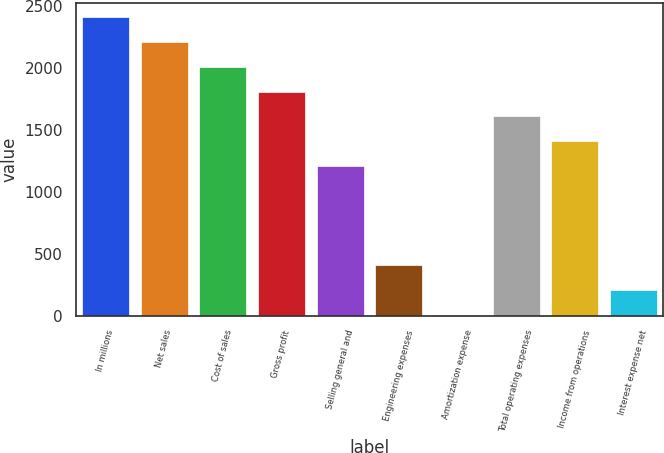Convert chart. <chart><loc_0><loc_0><loc_500><loc_500><bar_chart><fcel>In millions<fcel>Net sales<fcel>Cost of sales<fcel>Gross profit<fcel>Selling general and<fcel>Engineering expenses<fcel>Amortization expense<fcel>Total operating expenses<fcel>Income from operations<fcel>Interest expense net<nl><fcel>2409.96<fcel>2209.98<fcel>2010<fcel>1810.02<fcel>1210.08<fcel>410.16<fcel>10.2<fcel>1610.04<fcel>1410.06<fcel>210.18<nl></chart> 